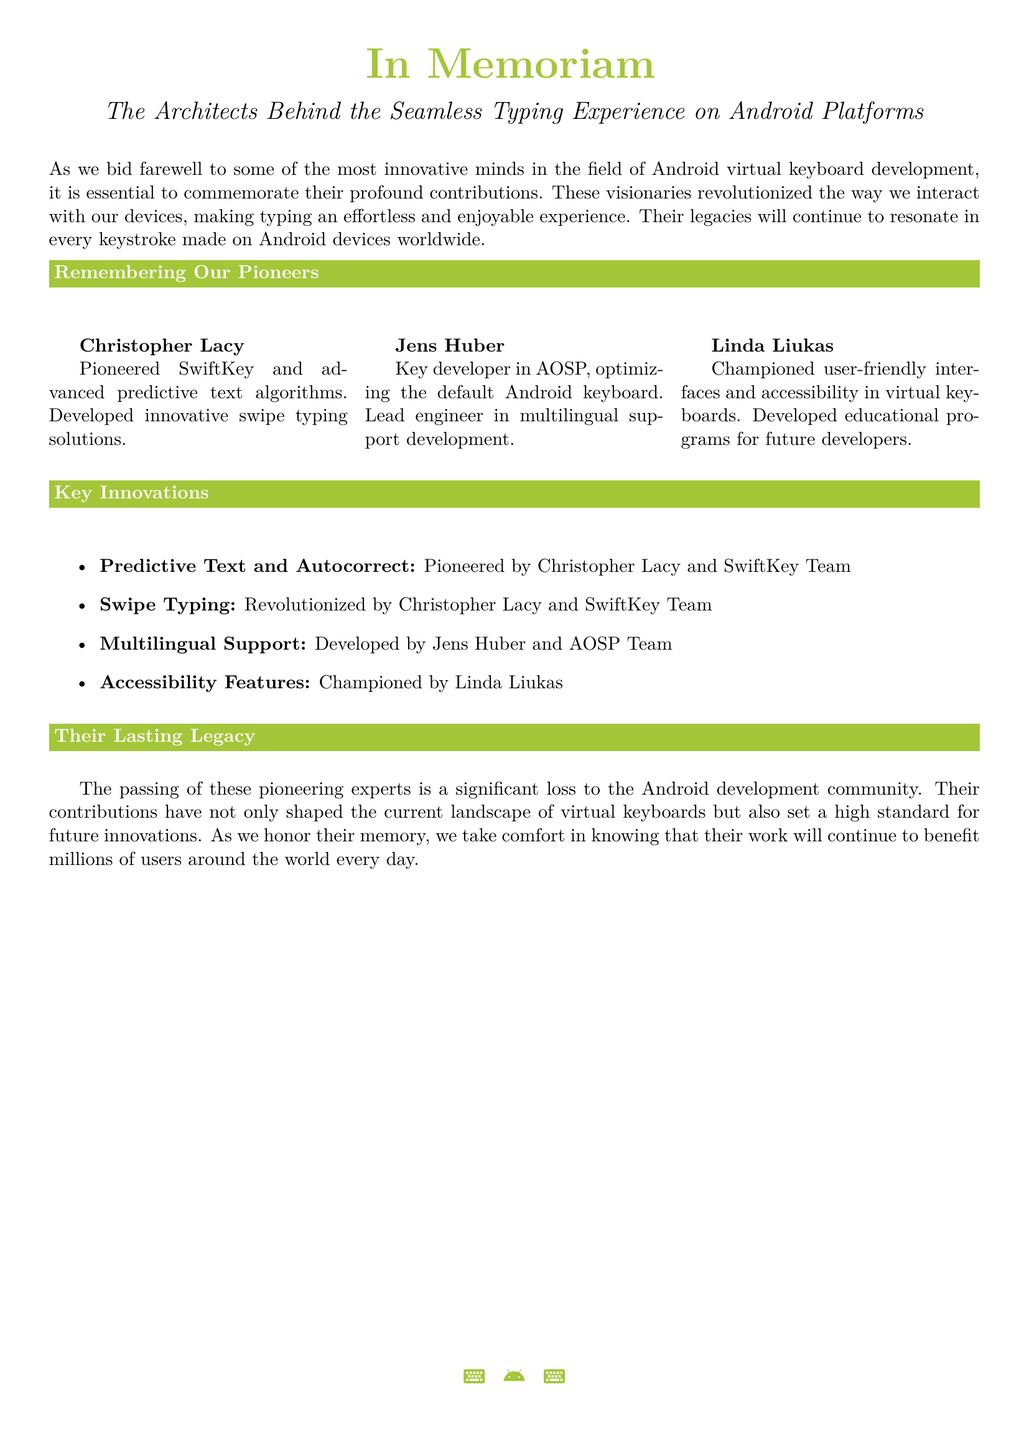What is the title of the document? The title of the document is presented prominently at the beginning, highlighting its focus on remembrance and tribute.
Answer: In Memoriam: The Architects Behind the Seamless Typing Experience on Android Platforms Who pioneered SwiftKey? This information is provided in the section about remembering the pioneers of Android virtual keyboard development.
Answer: Christopher Lacy What feature was developed by Jens Huber? The document mentions various features and attributes linked to the developers, specifically highlighting Jens Huber's contributions.
Answer: Multilingual Support Which feature was championed by Linda Liukas? The document describes the key innovations and attributes attributed to each pioneer, including Linda Liukas’s contributions.
Answer: Accessibility Features How many pioneers are commemorated in the document? The structure of the document lists out three specific contributors to Android virtual keyboard development.
Answer: Three What color is used for the section titles? The description of the document includes details on specific color themes applied throughout the text, particularly for section titles.
Answer: Android green What is the purpose of the document? The introduction of the document outlines its intention to remember and celebrate significant contributions to Android keyboard development.
Answer: Commemorate contributions Which typing solution did Christopher Lacy advance? The document explicitly states the innovations brought forth by Christopher Lacy in relation to keyboard functionality.
Answer: Predictive text algorithms 